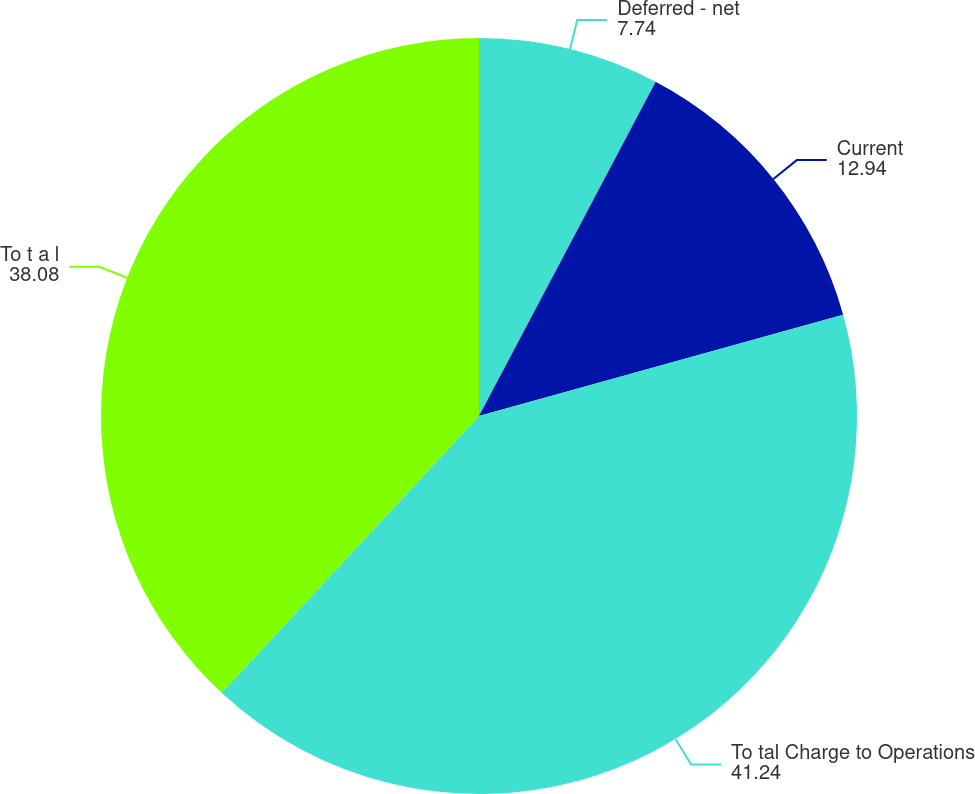Convert chart to OTSL. <chart><loc_0><loc_0><loc_500><loc_500><pie_chart><fcel>Deferred - net<fcel>Current<fcel>To tal Charge to Operations<fcel>To t a l<nl><fcel>7.74%<fcel>12.94%<fcel>41.24%<fcel>38.08%<nl></chart> 